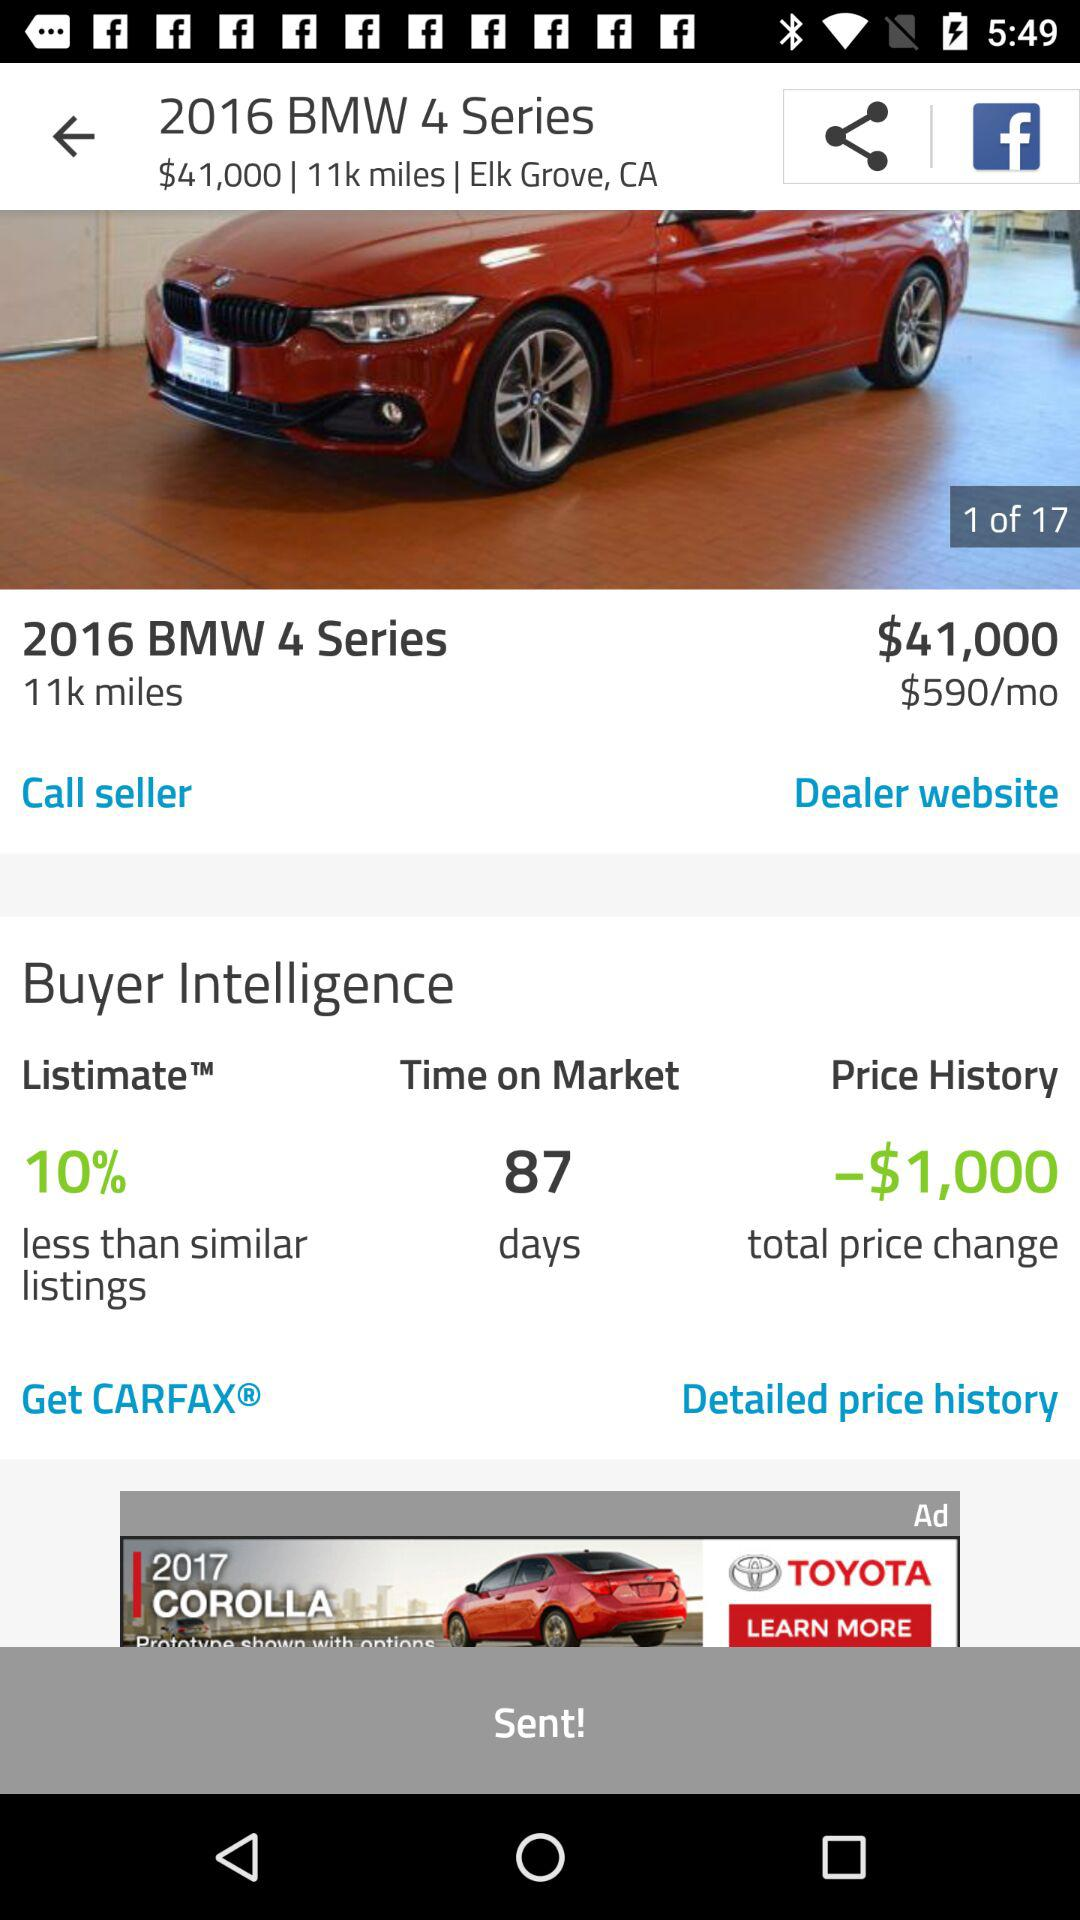How many days are shown in "Time on Market"? The shown days are 87. 